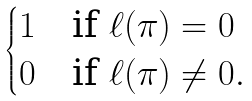Convert formula to latex. <formula><loc_0><loc_0><loc_500><loc_500>\begin{cases} 1 & \text {if } \ell ( \pi ) = 0 \\ 0 & \text {if } \ell ( \pi ) \neq 0 . \end{cases}</formula> 